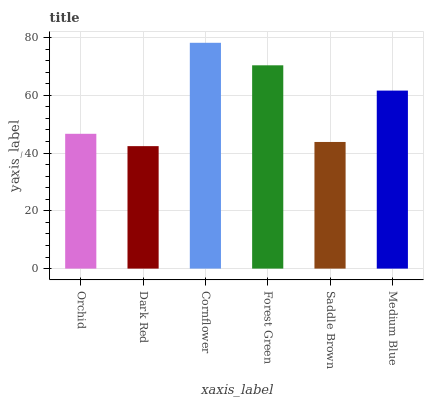Is Cornflower the minimum?
Answer yes or no. No. Is Dark Red the maximum?
Answer yes or no. No. Is Cornflower greater than Dark Red?
Answer yes or no. Yes. Is Dark Red less than Cornflower?
Answer yes or no. Yes. Is Dark Red greater than Cornflower?
Answer yes or no. No. Is Cornflower less than Dark Red?
Answer yes or no. No. Is Medium Blue the high median?
Answer yes or no. Yes. Is Orchid the low median?
Answer yes or no. Yes. Is Orchid the high median?
Answer yes or no. No. Is Cornflower the low median?
Answer yes or no. No. 